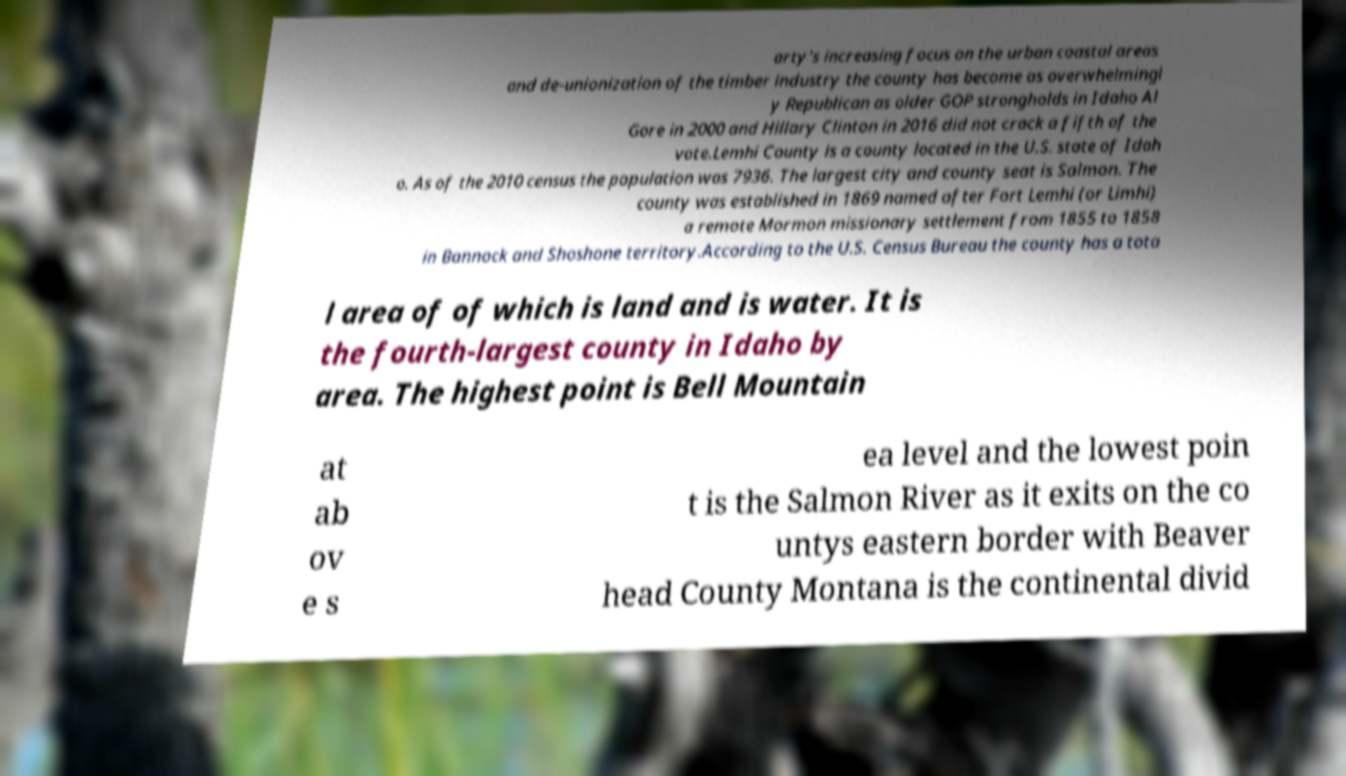What messages or text are displayed in this image? I need them in a readable, typed format. arty's increasing focus on the urban coastal areas and de-unionization of the timber industry the county has become as overwhelmingl y Republican as older GOP strongholds in Idaho Al Gore in 2000 and Hillary Clinton in 2016 did not crack a fifth of the vote.Lemhi County is a county located in the U.S. state of Idah o. As of the 2010 census the population was 7936. The largest city and county seat is Salmon. The county was established in 1869 named after Fort Lemhi (or Limhi) a remote Mormon missionary settlement from 1855 to 1858 in Bannock and Shoshone territory.According to the U.S. Census Bureau the county has a tota l area of of which is land and is water. It is the fourth-largest county in Idaho by area. The highest point is Bell Mountain at ab ov e s ea level and the lowest poin t is the Salmon River as it exits on the co untys eastern border with Beaver head County Montana is the continental divid 